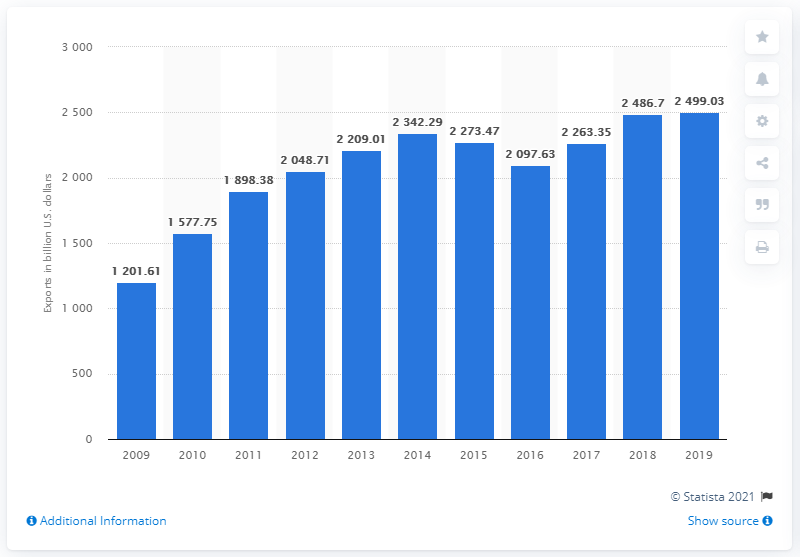List a handful of essential elements in this visual. In 2019, China exported a total of $2499.03 worth of goods. In 2019, China's export value experienced a significant growth of 2499.03%. 